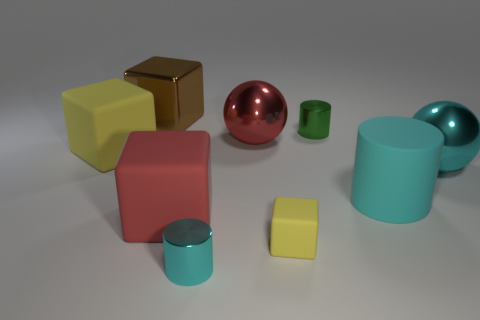How many metal things are either purple spheres or brown blocks?
Your answer should be compact. 1. The green thing has what shape?
Provide a short and direct response. Cylinder. How many yellow blocks are made of the same material as the big cyan cylinder?
Keep it short and to the point. 2. There is a cube that is made of the same material as the tiny green cylinder; what color is it?
Offer a terse response. Brown. Does the cyan cylinder right of the cyan metal cylinder have the same size as the brown shiny thing?
Ensure brevity in your answer.  Yes. What color is the tiny rubber thing that is the same shape as the brown metallic object?
Make the answer very short. Yellow. What is the shape of the yellow rubber thing that is behind the metallic ball that is in front of the yellow block that is on the left side of the red shiny object?
Provide a succinct answer. Cube. Do the red matte thing and the big cyan rubber thing have the same shape?
Offer a very short reply. No. There is a big shiny object in front of the yellow matte cube that is left of the small cyan cylinder; what is its shape?
Your response must be concise. Sphere. Is there a purple sphere?
Give a very brief answer. No. 